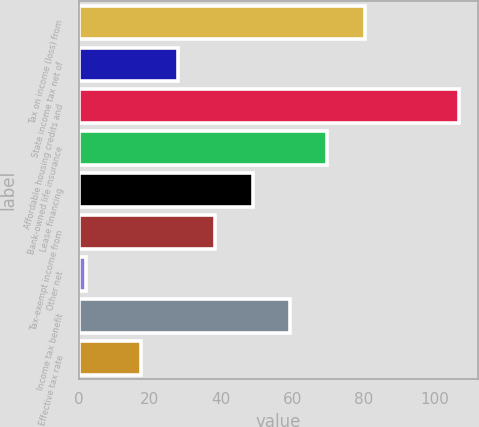Convert chart. <chart><loc_0><loc_0><loc_500><loc_500><bar_chart><fcel>Tax on income (loss) from<fcel>State income tax net of<fcel>Affordable housing credits and<fcel>Bank-owned life insurance<fcel>Lease financing<fcel>Tax-exempt income from<fcel>Other net<fcel>Income tax benefit<fcel>Effective tax rate<nl><fcel>80.4<fcel>27.9<fcel>107<fcel>69.9<fcel>48.9<fcel>38.4<fcel>2<fcel>59.4<fcel>17.4<nl></chart> 